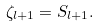Convert formula to latex. <formula><loc_0><loc_0><loc_500><loc_500>\zeta _ { l + 1 } = S _ { l + 1 } .</formula> 